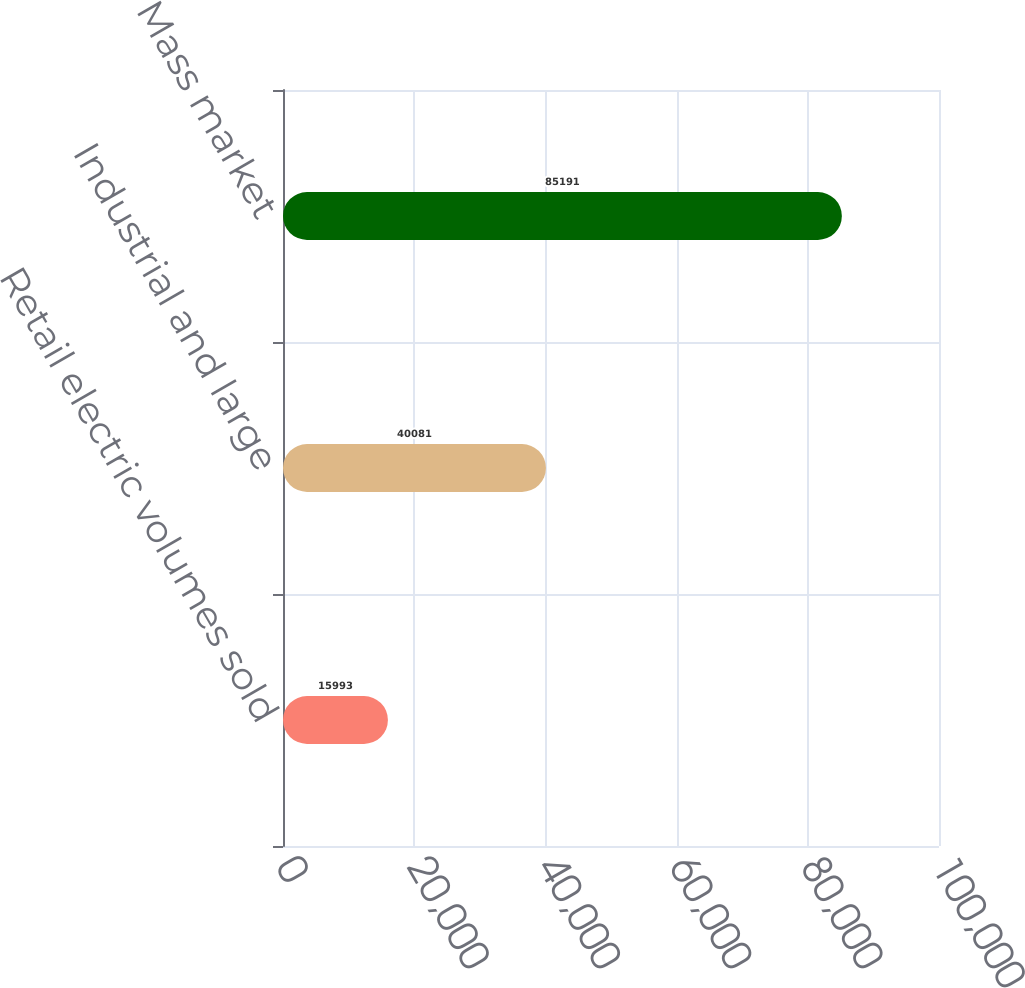<chart> <loc_0><loc_0><loc_500><loc_500><bar_chart><fcel>Retail electric volumes sold<fcel>Industrial and large<fcel>Mass market<nl><fcel>15993<fcel>40081<fcel>85191<nl></chart> 